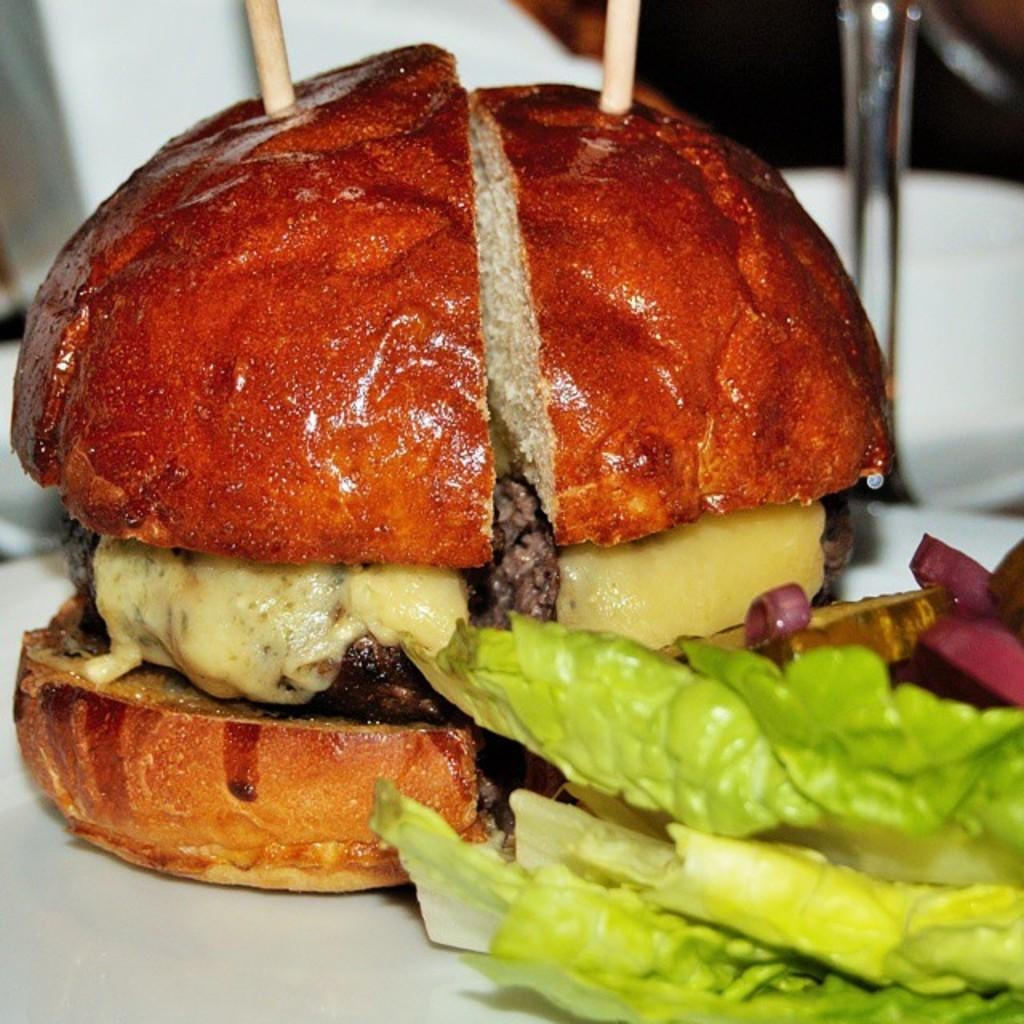What type of food can be seen in the image? The image contains food, but the specific type cannot be determined from the provided facts. What utensils or tools are present in the image? Toothpicks are visible in the image. Can you describe the background of the image? The background of the image is blurred. What organization is the mother representing in the image? There is no mention of a mother or an organization in the image. 